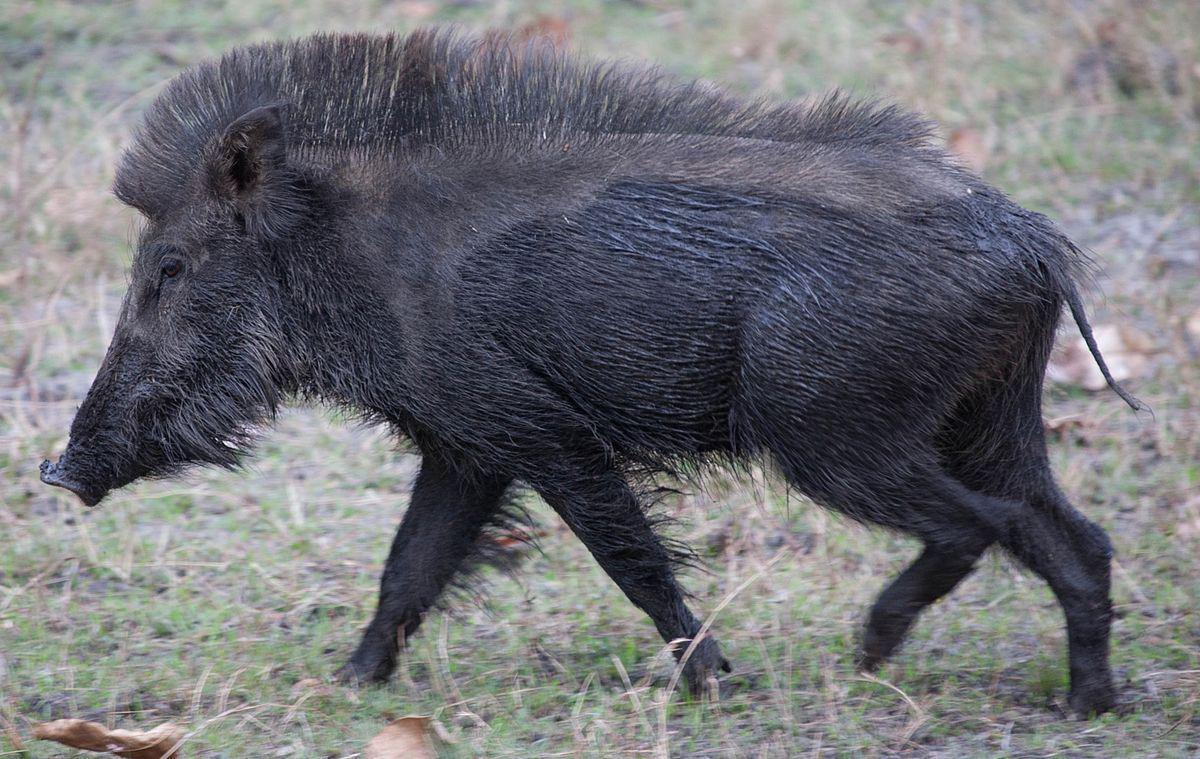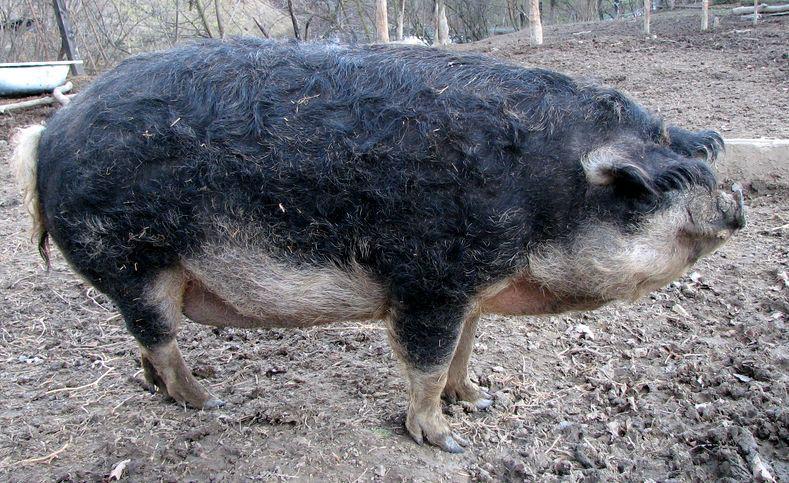The first image is the image on the left, the second image is the image on the right. Considering the images on both sides, is "The hogs in the pair of images face opposite directions." valid? Answer yes or no. Yes. 